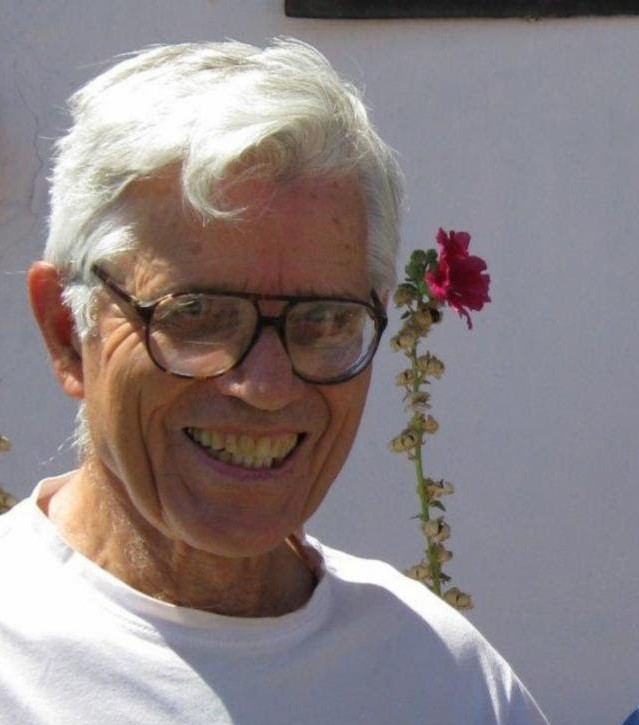Create a wild imaginary scenario involving the man and the flower. Once upon a time, in a secret garden hidden from the world, an elderly man named Professor Thistle stumbled upon a mystical red carnation. This was no ordinary flower; legends whispered that it had the power to grant wishes. Intrigued and amused, Professor Thistle playfully placed the flower atop his head, not expecting much to happen. Suddenly, the flower's petals began to glow, and he was whisked away into a fantastical adventure. He found himself in a land where flowers spoke, rivers sang, and clouds painted the sky in ever-changing hues. The wise carnation guided him through enchanted forests and towering mountains, revealing the secrets of nature and the universe. Throughout his journey, Professor Thistle discovered hidden strengths and ancient wisdom, ultimately realizing that the true magic lay within him all along. With a heart full of newfound knowledge and joy, he returned to his garden, forever changed by the whimsical and wondrous journey, the red carnation still blooming brightly atop his head. 